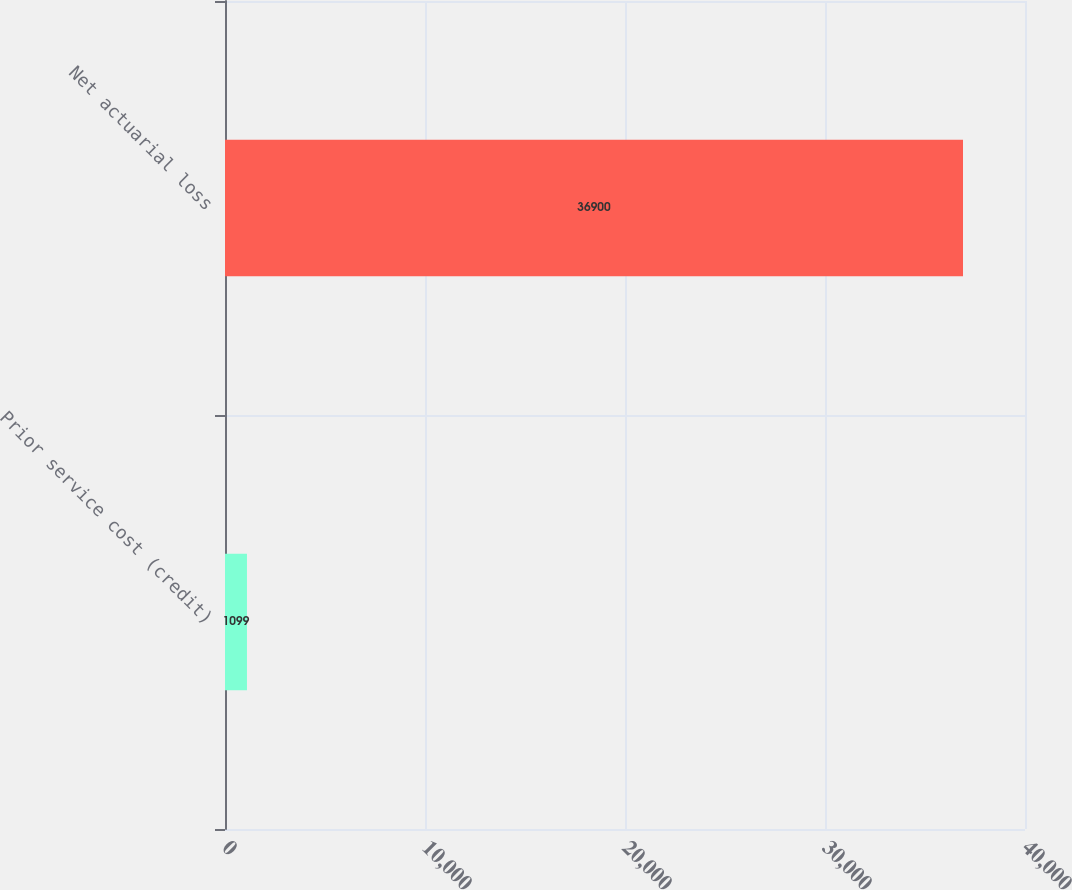Convert chart. <chart><loc_0><loc_0><loc_500><loc_500><bar_chart><fcel>Prior service cost (credit)<fcel>Net actuarial loss<nl><fcel>1099<fcel>36900<nl></chart> 